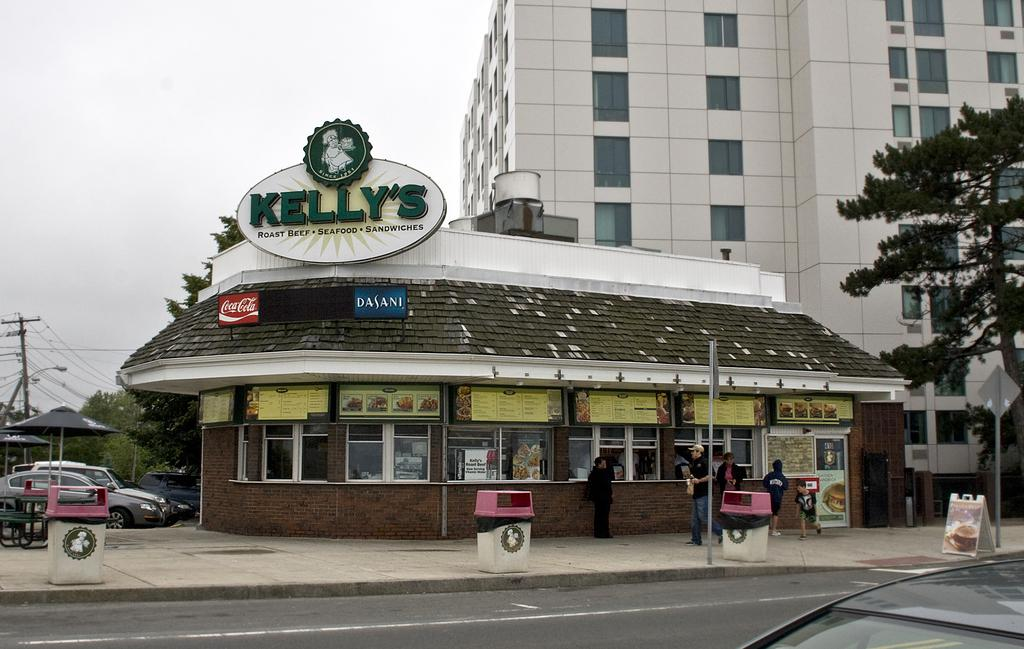What type of structure is visible in the image? There is a building in the image. What can be seen on the left side of the image? There are cars on the left side of the image. What type of temporary shelter is present in the image? There is a tent in the image. What type of vegetation is visible in the image? There are trees in the image. What is visible at the top of the image? The sky is visible at the top of the image. What type of mint or berry is growing on the building in the image? There is no mention of mint or berry in the image; the focus is on the building, cars, tent, trees, and sky. 